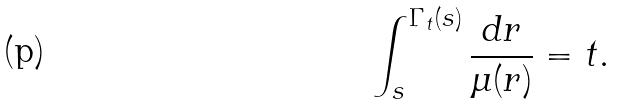<formula> <loc_0><loc_0><loc_500><loc_500>\int _ { s } ^ { \Gamma _ { t } ( s ) } \frac { d r } { \mu ( r ) } = t .</formula> 